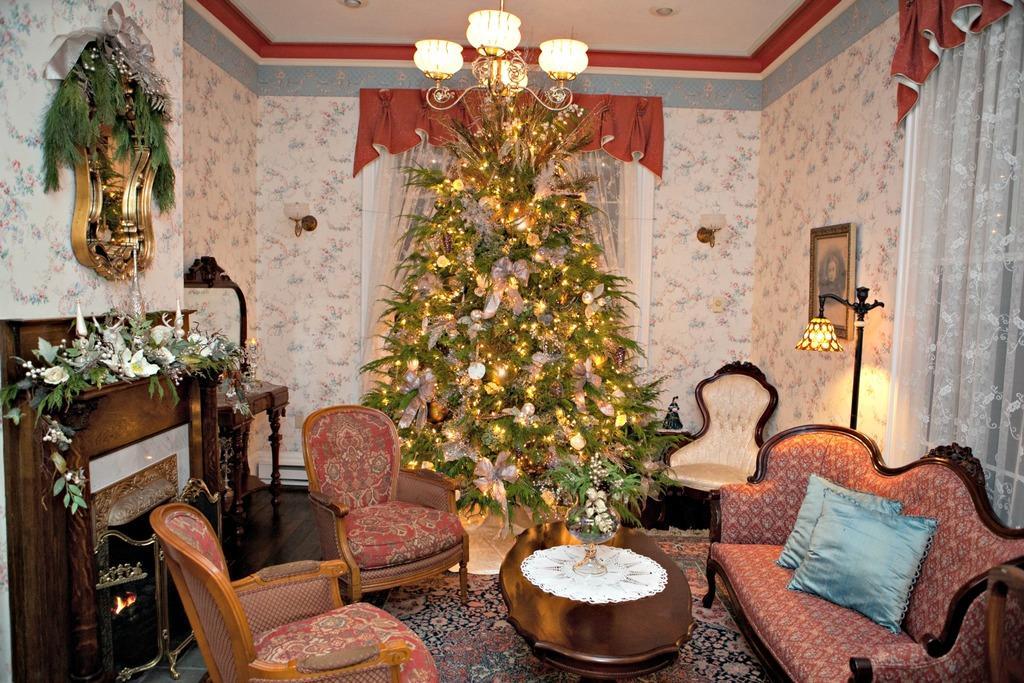How would you summarize this image in a sentence or two? There is a sofa set which is red in color and there is a tree behind the sofa set and the walls are white in color. 